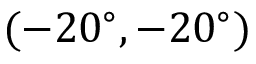Convert formula to latex. <formula><loc_0><loc_0><loc_500><loc_500>( - 2 0 ^ { \circ } , - 2 0 ^ { \circ } )</formula> 